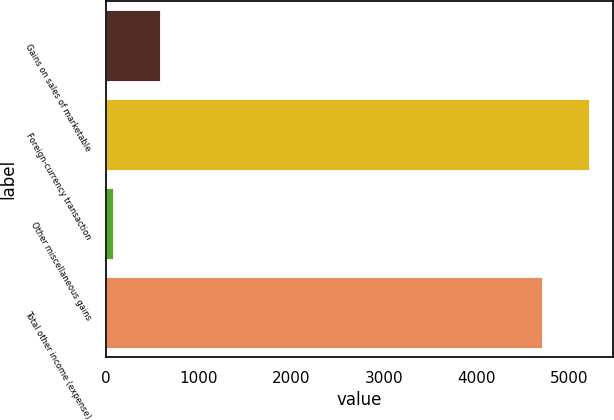Convert chart. <chart><loc_0><loc_0><loc_500><loc_500><bar_chart><fcel>Gains on sales of marketable<fcel>Foreign-currency transaction<fcel>Other miscellaneous gains<fcel>Total other income (expense)<nl><fcel>587.1<fcel>5215.1<fcel>73<fcel>4701<nl></chart> 